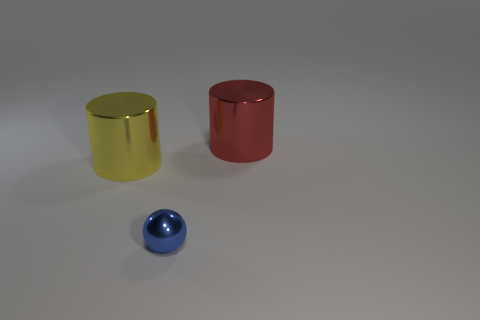What material is the blue ball? The blue ball appears to be made of a reflective material, such as polished metal or plastic with a metallic finish, due to the way it reflects light and its surroundings. 